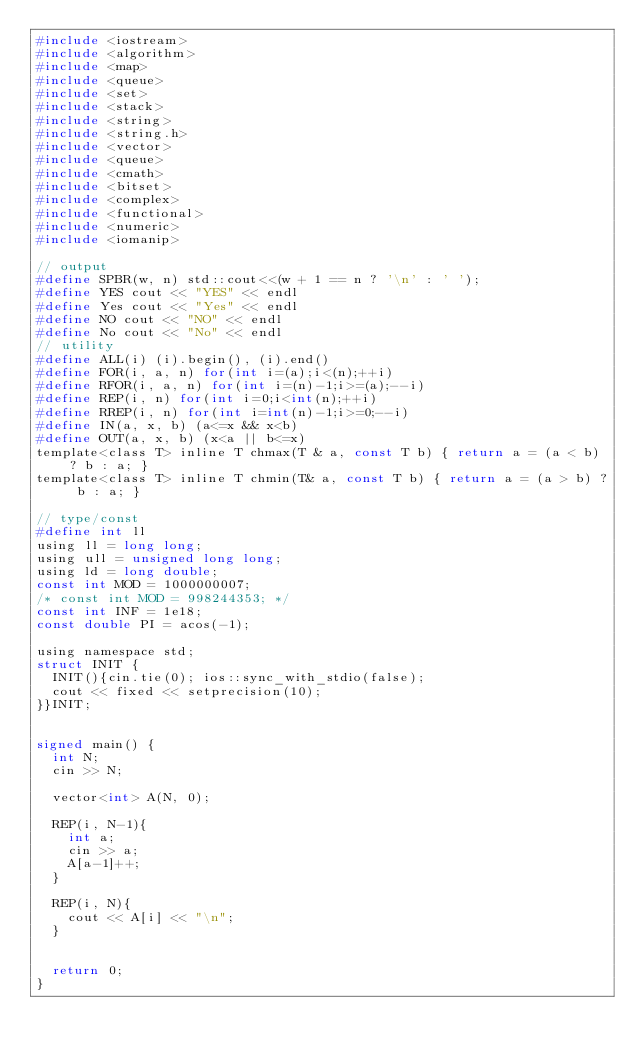Convert code to text. <code><loc_0><loc_0><loc_500><loc_500><_C_>#include <iostream>
#include <algorithm>
#include <map>
#include <queue>
#include <set>
#include <stack>
#include <string>
#include <string.h>
#include <vector>
#include <queue>
#include <cmath>
#include <bitset>
#include <complex>
#include <functional>
#include <numeric>
#include <iomanip>

// output
#define SPBR(w, n) std::cout<<(w + 1 == n ? '\n' : ' ');
#define YES cout << "YES" << endl
#define Yes cout << "Yes" << endl
#define NO cout << "NO" << endl
#define No cout << "No" << endl
// utility
#define ALL(i) (i).begin(), (i).end()
#define FOR(i, a, n) for(int i=(a);i<(n);++i)
#define RFOR(i, a, n) for(int i=(n)-1;i>=(a);--i)
#define REP(i, n) for(int i=0;i<int(n);++i)
#define RREP(i, n) for(int i=int(n)-1;i>=0;--i)
#define IN(a, x, b) (a<=x && x<b)
#define OUT(a, x, b) (x<a || b<=x)
template<class T> inline T chmax(T & a, const T b) { return a = (a < b) ? b : a; }
template<class T> inline T chmin(T& a, const T b) { return a = (a > b) ? b : a; }

// type/const
#define int ll
using ll = long long;
using ull = unsigned long long;
using ld = long double;
const int MOD = 1000000007;
/* const int MOD = 998244353; */
const int INF = 1e18;
const double PI = acos(-1);

using namespace std;
struct INIT { 
  INIT(){cin.tie(0); ios::sync_with_stdio(false);
  cout << fixed << setprecision(10);
}}INIT;


signed main() {
  int N; 
  cin >> N;

  vector<int> A(N, 0);

  REP(i, N-1){
    int a;
    cin >> a;
    A[a-1]++;
  }

  REP(i, N){
    cout << A[i] << "\n";
  }


  return 0;
}</code> 